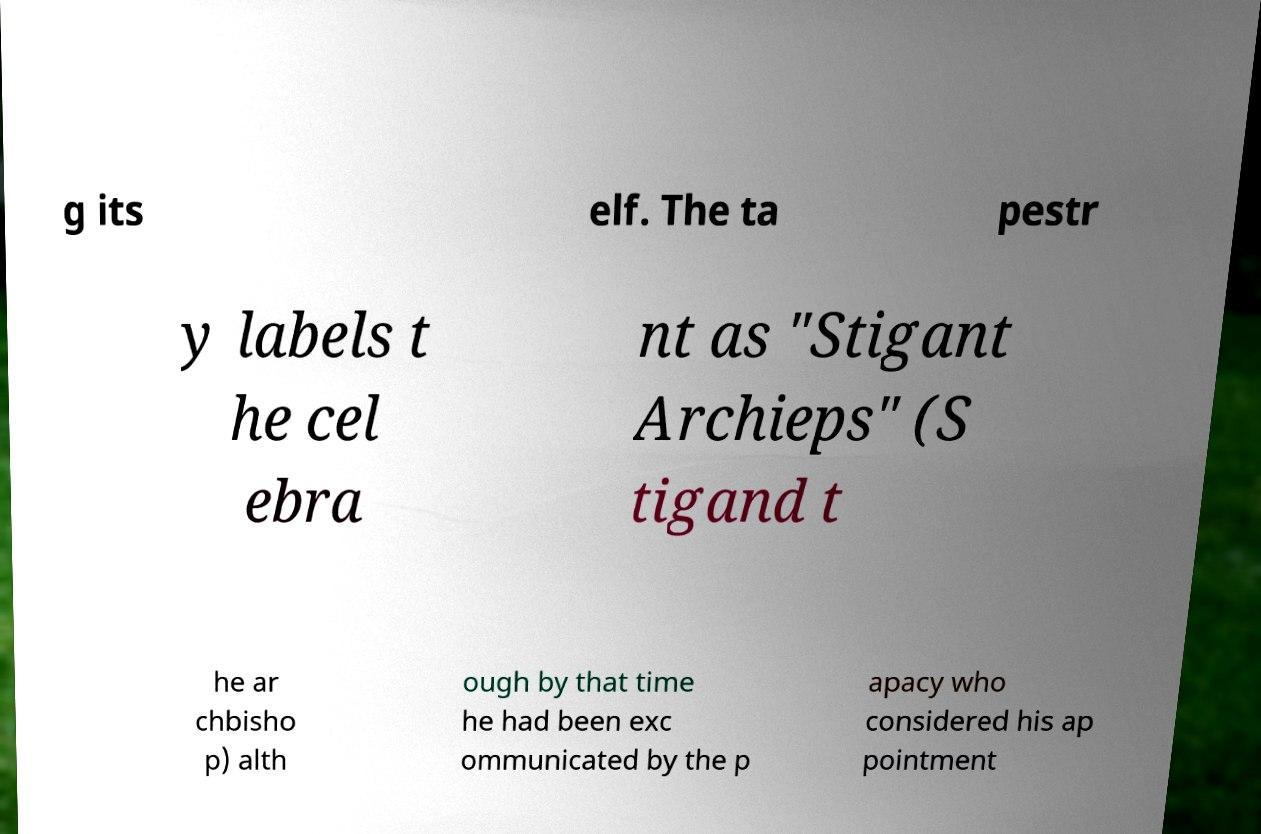Can you accurately transcribe the text from the provided image for me? g its elf. The ta pestr y labels t he cel ebra nt as "Stigant Archieps" (S tigand t he ar chbisho p) alth ough by that time he had been exc ommunicated by the p apacy who considered his ap pointment 